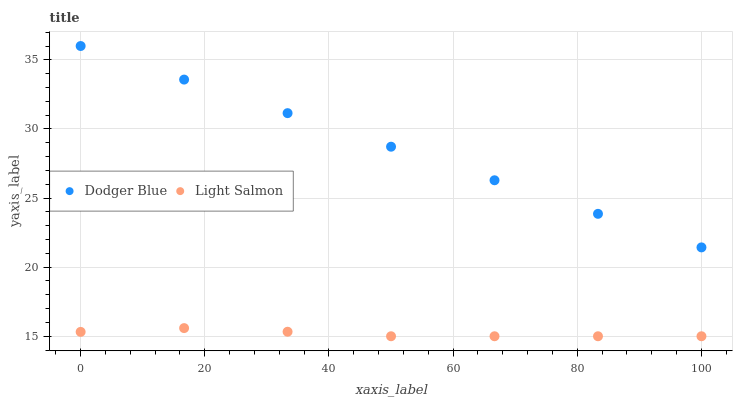Does Light Salmon have the minimum area under the curve?
Answer yes or no. Yes. Does Dodger Blue have the maximum area under the curve?
Answer yes or no. Yes. Does Dodger Blue have the minimum area under the curve?
Answer yes or no. No. Is Dodger Blue the smoothest?
Answer yes or no. Yes. Is Light Salmon the roughest?
Answer yes or no. Yes. Is Dodger Blue the roughest?
Answer yes or no. No. Does Light Salmon have the lowest value?
Answer yes or no. Yes. Does Dodger Blue have the lowest value?
Answer yes or no. No. Does Dodger Blue have the highest value?
Answer yes or no. Yes. Is Light Salmon less than Dodger Blue?
Answer yes or no. Yes. Is Dodger Blue greater than Light Salmon?
Answer yes or no. Yes. Does Light Salmon intersect Dodger Blue?
Answer yes or no. No. 